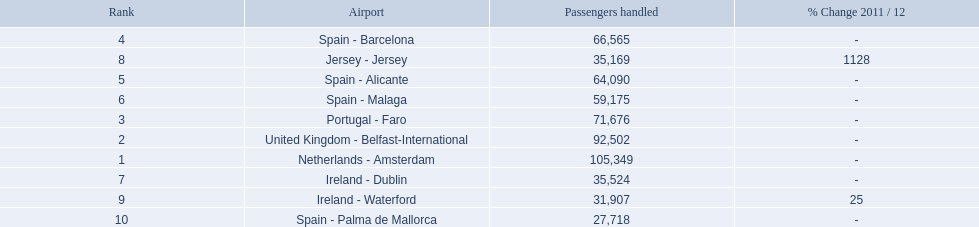What are the 10 busiest routes to and from london southend airport? Netherlands - Amsterdam, United Kingdom - Belfast-International, Portugal - Faro, Spain - Barcelona, Spain - Alicante, Spain - Malaga, Ireland - Dublin, Jersey - Jersey, Ireland - Waterford, Spain - Palma de Mallorca. Of these, which airport is in portugal? Portugal - Faro. 